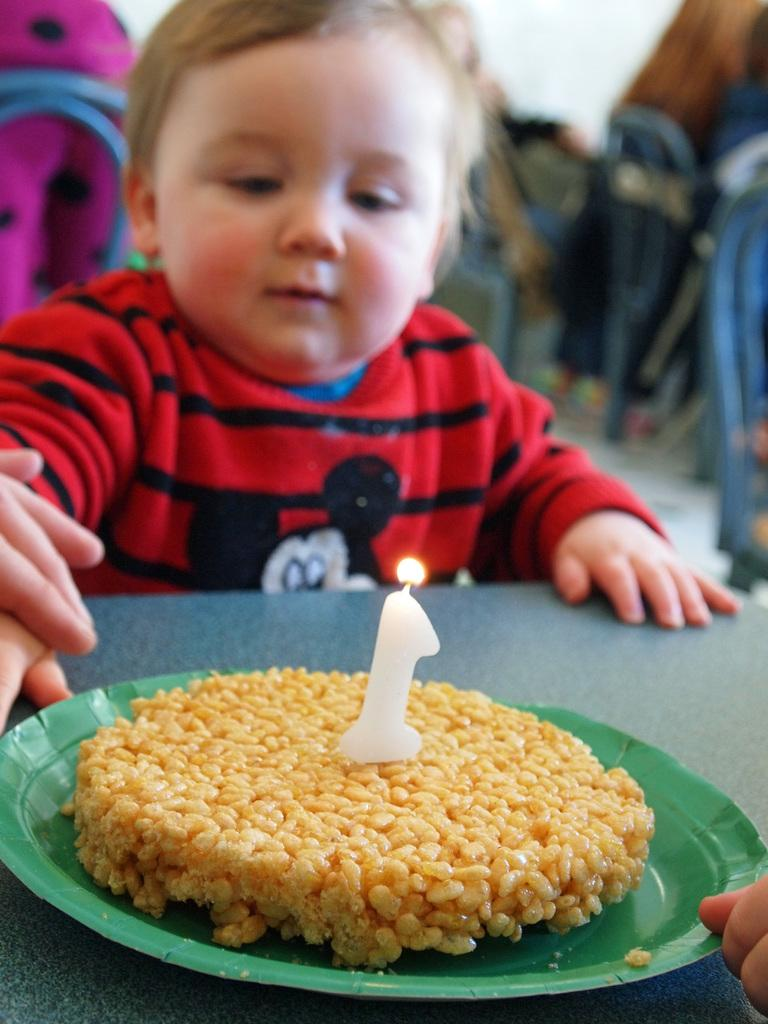What is on the plate that is visible in the image? There is a food item and a candle on the plate in the image. Where is the plate located? The plate is placed on a table. Who is present in the image? There is a kid and the fingers of a person in the image. How would you describe the background of the image? The background of the image is blurry. What type of temper does the achiever have in the image? There is no mention of an achiever or temper in the image; it only shows a plate with a food item and a candle, a table, a kid, and the fingers of a person. 